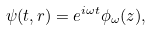Convert formula to latex. <formula><loc_0><loc_0><loc_500><loc_500>\psi ( t , r ) = e ^ { i \omega t } \phi _ { \omega } ( z ) ,</formula> 